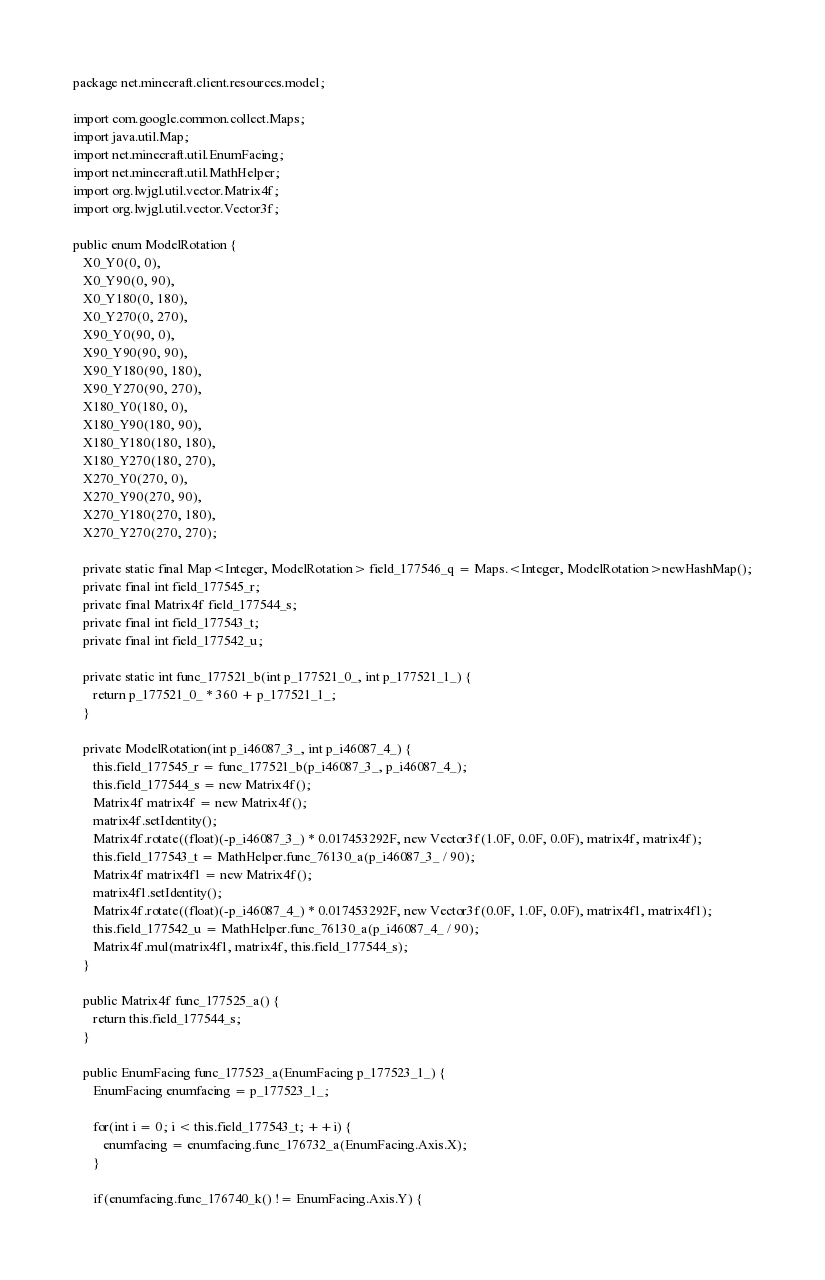<code> <loc_0><loc_0><loc_500><loc_500><_Java_>package net.minecraft.client.resources.model;

import com.google.common.collect.Maps;
import java.util.Map;
import net.minecraft.util.EnumFacing;
import net.minecraft.util.MathHelper;
import org.lwjgl.util.vector.Matrix4f;
import org.lwjgl.util.vector.Vector3f;

public enum ModelRotation {
   X0_Y0(0, 0),
   X0_Y90(0, 90),
   X0_Y180(0, 180),
   X0_Y270(0, 270),
   X90_Y0(90, 0),
   X90_Y90(90, 90),
   X90_Y180(90, 180),
   X90_Y270(90, 270),
   X180_Y0(180, 0),
   X180_Y90(180, 90),
   X180_Y180(180, 180),
   X180_Y270(180, 270),
   X270_Y0(270, 0),
   X270_Y90(270, 90),
   X270_Y180(270, 180),
   X270_Y270(270, 270);

   private static final Map<Integer, ModelRotation> field_177546_q = Maps.<Integer, ModelRotation>newHashMap();
   private final int field_177545_r;
   private final Matrix4f field_177544_s;
   private final int field_177543_t;
   private final int field_177542_u;

   private static int func_177521_b(int p_177521_0_, int p_177521_1_) {
      return p_177521_0_ * 360 + p_177521_1_;
   }

   private ModelRotation(int p_i46087_3_, int p_i46087_4_) {
      this.field_177545_r = func_177521_b(p_i46087_3_, p_i46087_4_);
      this.field_177544_s = new Matrix4f();
      Matrix4f matrix4f = new Matrix4f();
      matrix4f.setIdentity();
      Matrix4f.rotate((float)(-p_i46087_3_) * 0.017453292F, new Vector3f(1.0F, 0.0F, 0.0F), matrix4f, matrix4f);
      this.field_177543_t = MathHelper.func_76130_a(p_i46087_3_ / 90);
      Matrix4f matrix4f1 = new Matrix4f();
      matrix4f1.setIdentity();
      Matrix4f.rotate((float)(-p_i46087_4_) * 0.017453292F, new Vector3f(0.0F, 1.0F, 0.0F), matrix4f1, matrix4f1);
      this.field_177542_u = MathHelper.func_76130_a(p_i46087_4_ / 90);
      Matrix4f.mul(matrix4f1, matrix4f, this.field_177544_s);
   }

   public Matrix4f func_177525_a() {
      return this.field_177544_s;
   }

   public EnumFacing func_177523_a(EnumFacing p_177523_1_) {
      EnumFacing enumfacing = p_177523_1_;

      for(int i = 0; i < this.field_177543_t; ++i) {
         enumfacing = enumfacing.func_176732_a(EnumFacing.Axis.X);
      }

      if(enumfacing.func_176740_k() != EnumFacing.Axis.Y) {</code> 